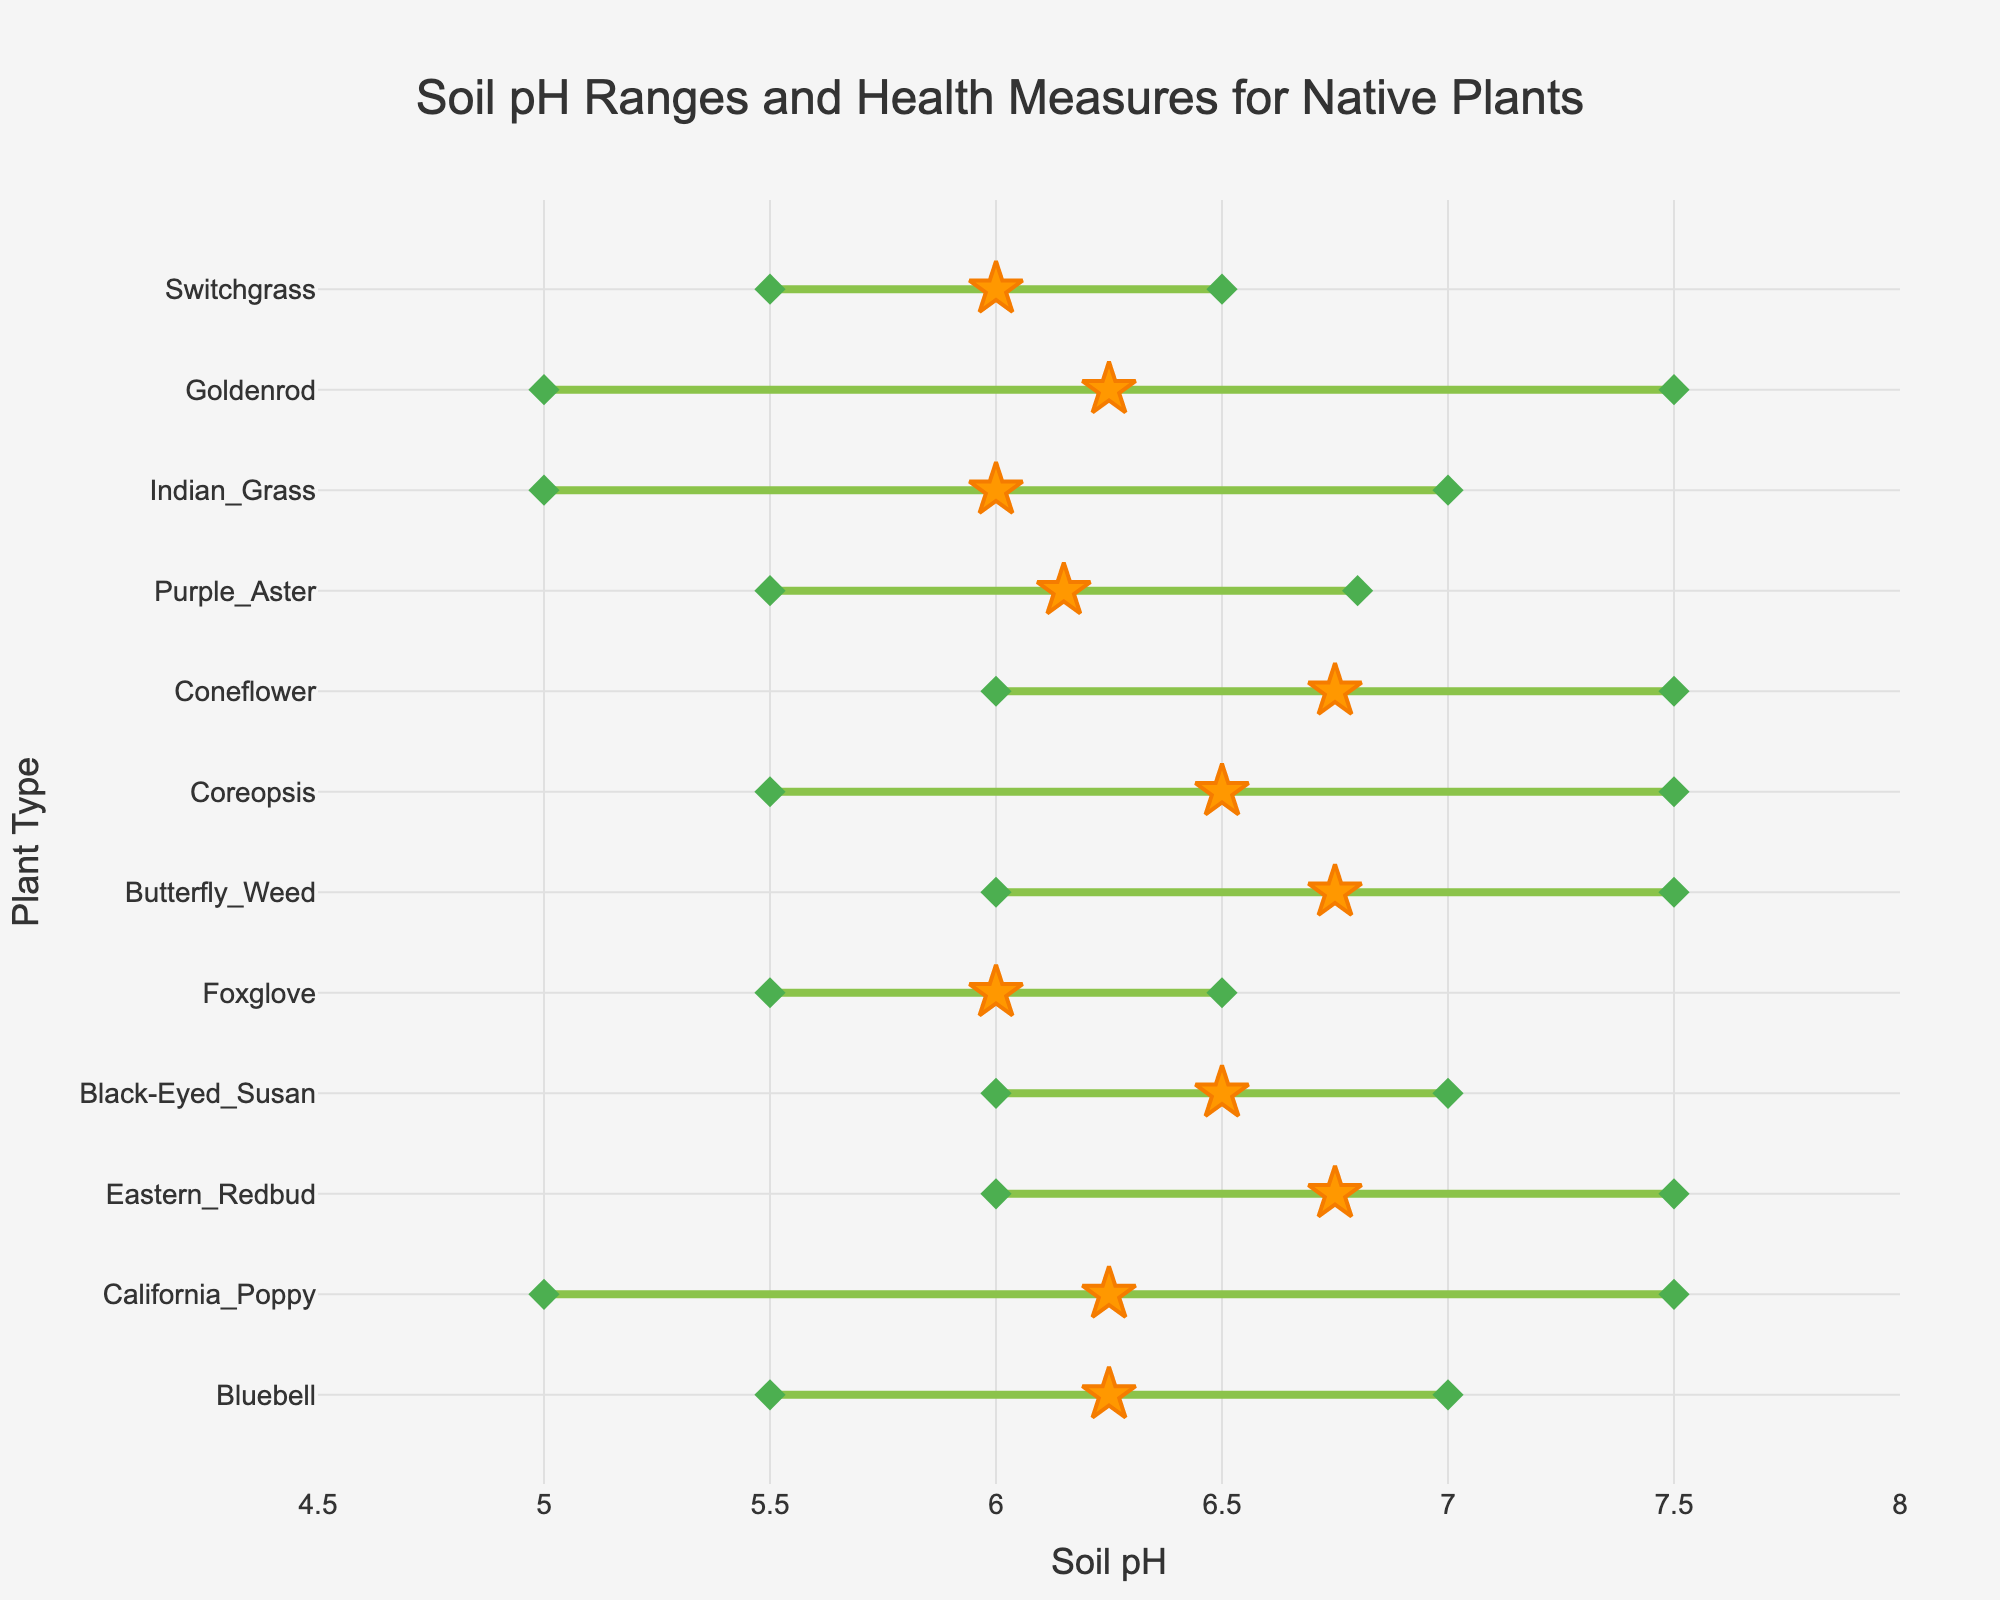What is the title of the figure? The title is located at the top center of the figure.
Answer: Soil pH Ranges and Health Measures for Native Plants What is the soil pH range for Bluebell? Bluebell's range is depicted by the horizontal line and markers associated with its name on the y-axis.
Answer: 5.5 to 7.0 Which plant type has the highest health measure? Observing the star markers and their hover information, Coreopsis has the highest health measure.
Answer: Coreopsis How many plant types have a soil pH range that starts at 5.5? By checking each plant type's soil pH range, we can count the lines that start at 5.5. Those are Bluebell, Foxglove, Coreopsis, Purple Aster, and Switchgrass.
Answer: 5 What is the average maximum soil pH level of all plants? Sum the maximum pH levels and divide by the number of plant types: (7.0 + 7.5 + 7.5 + 7.0 + 6.5 + 7.5 + 7.5 + 7.5 + 6.8 + 7.0 + 7.5 + 6.5) / 12.
Answer: 7.0 Which plant type has the smallest soil pH range? By checking the lengths of the lines representing soil pH ranges, Foxglove (1.0) has the smallest range.
Answer: Foxglove Is the soil pH range for Coneflower higher than that for Black-Eyed Susan? Coneflower's range is 6.0 to 7.5, and Black-Eyed Susan's range is 6.0 to 7.0. So, Coneflower's maximum pH is greater.
Answer: Yes How many plant types have a health measure higher than 9.0? By hovering and checking the health measure values, California Poppy, Eastern Redbud, Coreopsis, and Goldenrod are above 9.0.
Answer: 4 Which plant type has a midpoint soil pH closest to 6.5? Calculate the midpoints for each plant and find the closest to 6.5. For instance, Bluebell: (5.5+7.0)/2=6.25, California Poppy: (5.0+7.5)/2=6.25, and so on. Purple Aster is (5.5+6.8)/2=6.15, which is closest.
Answer: Purple Aster Which plants have overlapping soil pH ranges with Eastern Redbud? Eastern Redbud ranges from 6.0 to 7.5. Plants with overlapping ranges are Black-Eyed Susan, Butterfly Weed, Coneflower, and Goldenrod.
Answer: Black-Eyed Susan, Butterfly Weed, Coneflower, Goldenrod 